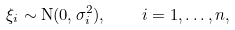Convert formula to latex. <formula><loc_0><loc_0><loc_500><loc_500>\xi _ { i } \sim \mathrm N ( 0 , \sigma _ { i } ^ { 2 } ) , \quad i = 1 , \dots , n ,</formula> 